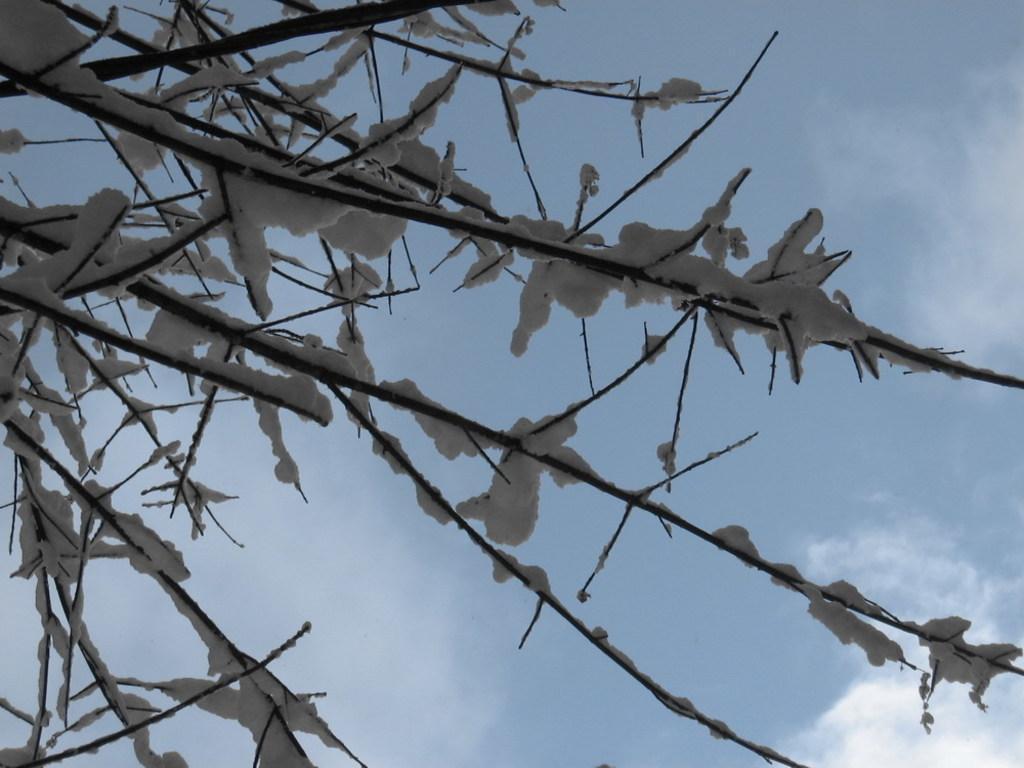Can you describe this image briefly? In this image we can see branches with snow. In the background there is sky with clouds. 